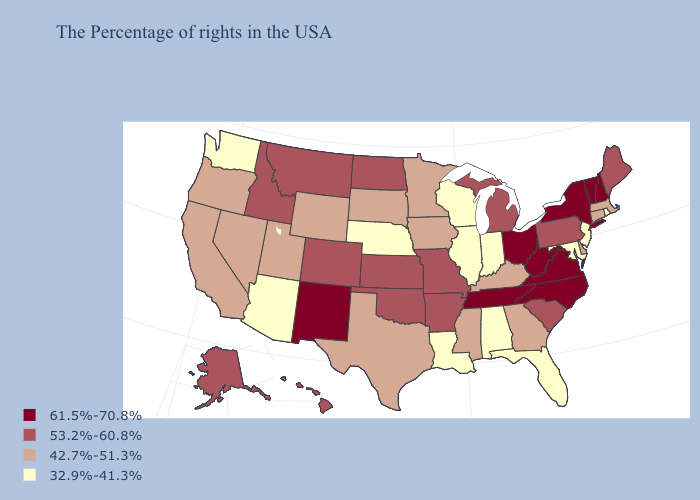What is the lowest value in the West?
Concise answer only. 32.9%-41.3%. Does Maine have the lowest value in the Northeast?
Be succinct. No. Does the first symbol in the legend represent the smallest category?
Answer briefly. No. What is the value of Florida?
Give a very brief answer. 32.9%-41.3%. Among the states that border Florida , does Georgia have the lowest value?
Write a very short answer. No. What is the value of Alaska?
Concise answer only. 53.2%-60.8%. Among the states that border Florida , which have the lowest value?
Quick response, please. Alabama. Does South Dakota have the lowest value in the USA?
Keep it brief. No. What is the value of North Carolina?
Give a very brief answer. 61.5%-70.8%. Name the states that have a value in the range 42.7%-51.3%?
Give a very brief answer. Massachusetts, Connecticut, Delaware, Georgia, Kentucky, Mississippi, Minnesota, Iowa, Texas, South Dakota, Wyoming, Utah, Nevada, California, Oregon. Does Tennessee have the highest value in the USA?
Concise answer only. Yes. Does Kansas have the lowest value in the MidWest?
Give a very brief answer. No. Name the states that have a value in the range 53.2%-60.8%?
Short answer required. Maine, Pennsylvania, South Carolina, Michigan, Missouri, Arkansas, Kansas, Oklahoma, North Dakota, Colorado, Montana, Idaho, Alaska, Hawaii. Which states have the lowest value in the USA?
Short answer required. Rhode Island, New Jersey, Maryland, Florida, Indiana, Alabama, Wisconsin, Illinois, Louisiana, Nebraska, Arizona, Washington. Name the states that have a value in the range 42.7%-51.3%?
Keep it brief. Massachusetts, Connecticut, Delaware, Georgia, Kentucky, Mississippi, Minnesota, Iowa, Texas, South Dakota, Wyoming, Utah, Nevada, California, Oregon. 